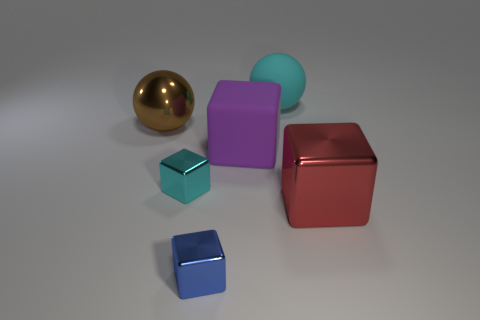There is another big metal object that is the same shape as the blue shiny object; what is its color?
Keep it short and to the point. Red. Is the number of large purple metallic cubes less than the number of red blocks?
Your answer should be very brief. Yes. Do the cyan sphere and the block that is right of the big rubber cube have the same size?
Give a very brief answer. Yes. The sphere behind the big thing that is on the left side of the cyan block is what color?
Offer a very short reply. Cyan. What number of things are small blocks that are behind the blue cube or small things that are behind the big metal block?
Make the answer very short. 1. Do the matte ball and the red block have the same size?
Your answer should be compact. Yes. Are there any other things that have the same size as the brown metal ball?
Your answer should be very brief. Yes. Does the tiny metallic thing that is behind the blue shiny cube have the same shape as the metallic object to the right of the blue metallic thing?
Your answer should be very brief. Yes. What size is the matte ball?
Your response must be concise. Large. There is a object in front of the large red metal block that is on the right side of the sphere that is to the left of the large matte sphere; what is it made of?
Your response must be concise. Metal. 